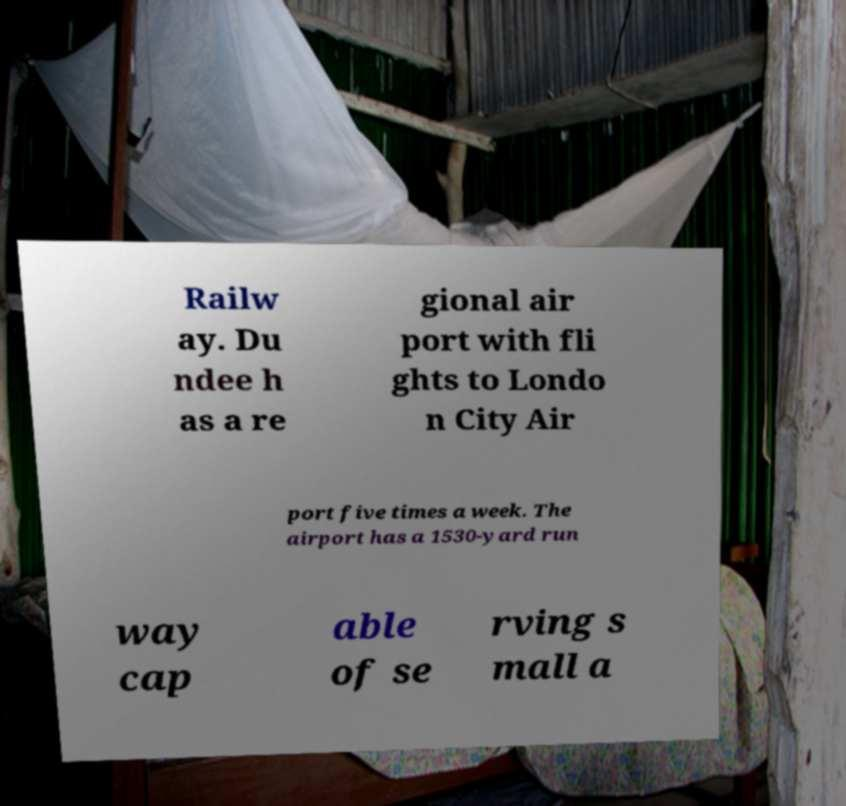Could you extract and type out the text from this image? Railw ay. Du ndee h as a re gional air port with fli ghts to Londo n City Air port five times a week. The airport has a 1530-yard run way cap able of se rving s mall a 